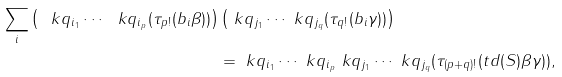Convert formula to latex. <formula><loc_0><loc_0><loc_500><loc_500>\sum _ { i } \left ( \ k q _ { i _ { 1 } } \cdots \ k q _ { i _ { p } } ( \tau _ { p ! } ( b _ { i } \beta ) ) \right ) & \left ( \ k q _ { j _ { 1 } } \cdots \ k q _ { j _ { q } } ( \tau _ { q ! } ( b _ { i } \gamma ) ) \right ) \\ & = \ k q _ { i _ { 1 } } \cdots \ k q _ { i _ { p } } \ k q _ { j _ { 1 } } \cdots \ k q _ { j _ { q } } ( \tau _ { ( p + q ) ! } ( t d ( S ) \beta \gamma ) ) ,</formula> 